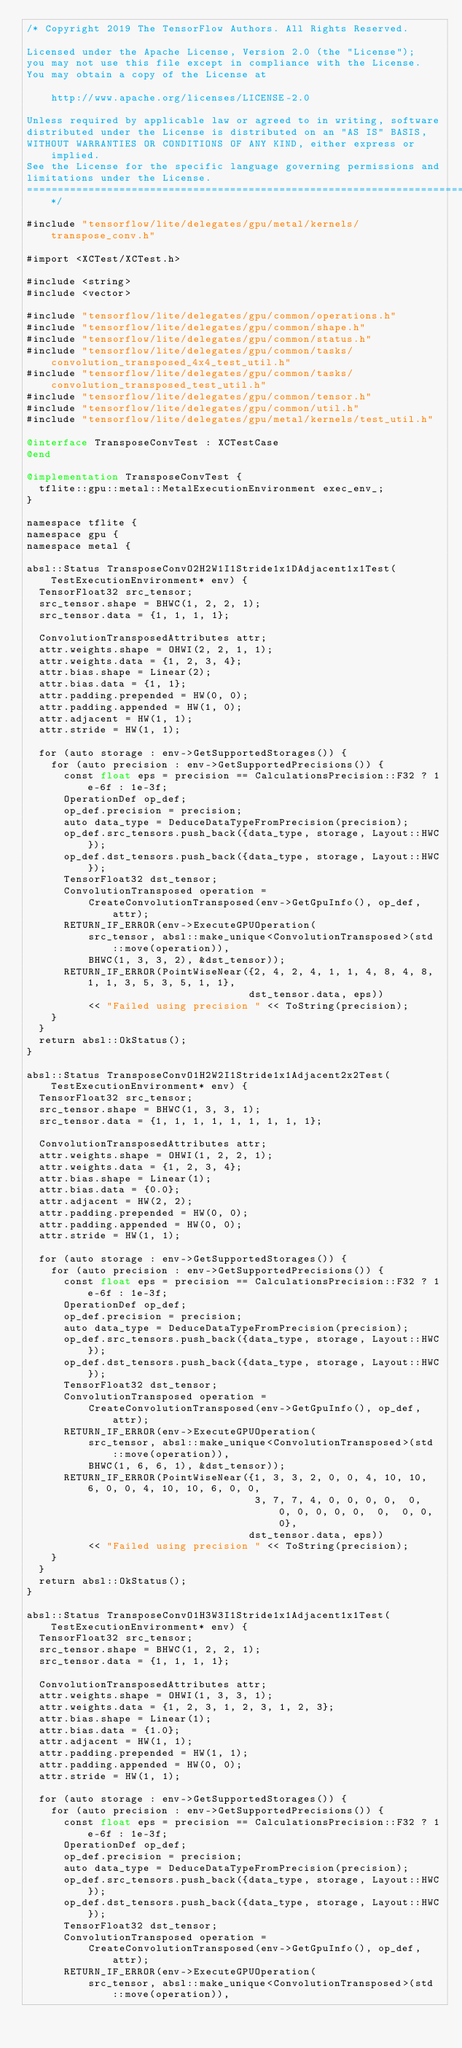<code> <loc_0><loc_0><loc_500><loc_500><_ObjectiveC_>/* Copyright 2019 The TensorFlow Authors. All Rights Reserved.

Licensed under the Apache License, Version 2.0 (the "License");
you may not use this file except in compliance with the License.
You may obtain a copy of the License at

    http://www.apache.org/licenses/LICENSE-2.0

Unless required by applicable law or agreed to in writing, software
distributed under the License is distributed on an "AS IS" BASIS,
WITHOUT WARRANTIES OR CONDITIONS OF ANY KIND, either express or implied.
See the License for the specific language governing permissions and
limitations under the License.
==============================================================================*/

#include "tensorflow/lite/delegates/gpu/metal/kernels/transpose_conv.h"

#import <XCTest/XCTest.h>

#include <string>
#include <vector>

#include "tensorflow/lite/delegates/gpu/common/operations.h"
#include "tensorflow/lite/delegates/gpu/common/shape.h"
#include "tensorflow/lite/delegates/gpu/common/status.h"
#include "tensorflow/lite/delegates/gpu/common/tasks/convolution_transposed_4x4_test_util.h"
#include "tensorflow/lite/delegates/gpu/common/tasks/convolution_transposed_test_util.h"
#include "tensorflow/lite/delegates/gpu/common/tensor.h"
#include "tensorflow/lite/delegates/gpu/common/util.h"
#include "tensorflow/lite/delegates/gpu/metal/kernels/test_util.h"

@interface TransposeConvTest : XCTestCase
@end

@implementation TransposeConvTest {
  tflite::gpu::metal::MetalExecutionEnvironment exec_env_;
}

namespace tflite {
namespace gpu {
namespace metal {

absl::Status TransposeConvO2H2W1I1Stride1x1DAdjacent1x1Test(TestExecutionEnvironment* env) {
  TensorFloat32 src_tensor;
  src_tensor.shape = BHWC(1, 2, 2, 1);
  src_tensor.data = {1, 1, 1, 1};

  ConvolutionTransposedAttributes attr;
  attr.weights.shape = OHWI(2, 2, 1, 1);
  attr.weights.data = {1, 2, 3, 4};
  attr.bias.shape = Linear(2);
  attr.bias.data = {1, 1};
  attr.padding.prepended = HW(0, 0);
  attr.padding.appended = HW(1, 0);
  attr.adjacent = HW(1, 1);
  attr.stride = HW(1, 1);

  for (auto storage : env->GetSupportedStorages()) {
    for (auto precision : env->GetSupportedPrecisions()) {
      const float eps = precision == CalculationsPrecision::F32 ? 1e-6f : 1e-3f;
      OperationDef op_def;
      op_def.precision = precision;
      auto data_type = DeduceDataTypeFromPrecision(precision);
      op_def.src_tensors.push_back({data_type, storage, Layout::HWC});
      op_def.dst_tensors.push_back({data_type, storage, Layout::HWC});
      TensorFloat32 dst_tensor;
      ConvolutionTransposed operation =
          CreateConvolutionTransposed(env->GetGpuInfo(), op_def, attr);
      RETURN_IF_ERROR(env->ExecuteGPUOperation(
          src_tensor, absl::make_unique<ConvolutionTransposed>(std::move(operation)),
          BHWC(1, 3, 3, 2), &dst_tensor));
      RETURN_IF_ERROR(PointWiseNear({2, 4, 2, 4, 1, 1, 4, 8, 4, 8, 1, 1, 3, 5, 3, 5, 1, 1},
                                    dst_tensor.data, eps))
          << "Failed using precision " << ToString(precision);
    }
  }
  return absl::OkStatus();
}

absl::Status TransposeConvO1H2W2I1Stride1x1Adjacent2x2Test(TestExecutionEnvironment* env) {
  TensorFloat32 src_tensor;
  src_tensor.shape = BHWC(1, 3, 3, 1);
  src_tensor.data = {1, 1, 1, 1, 1, 1, 1, 1, 1};

  ConvolutionTransposedAttributes attr;
  attr.weights.shape = OHWI(1, 2, 2, 1);
  attr.weights.data = {1, 2, 3, 4};
  attr.bias.shape = Linear(1);
  attr.bias.data = {0.0};
  attr.adjacent = HW(2, 2);
  attr.padding.prepended = HW(0, 0);
  attr.padding.appended = HW(0, 0);
  attr.stride = HW(1, 1);

  for (auto storage : env->GetSupportedStorages()) {
    for (auto precision : env->GetSupportedPrecisions()) {
      const float eps = precision == CalculationsPrecision::F32 ? 1e-6f : 1e-3f;
      OperationDef op_def;
      op_def.precision = precision;
      auto data_type = DeduceDataTypeFromPrecision(precision);
      op_def.src_tensors.push_back({data_type, storage, Layout::HWC});
      op_def.dst_tensors.push_back({data_type, storage, Layout::HWC});
      TensorFloat32 dst_tensor;
      ConvolutionTransposed operation =
          CreateConvolutionTransposed(env->GetGpuInfo(), op_def, attr);
      RETURN_IF_ERROR(env->ExecuteGPUOperation(
          src_tensor, absl::make_unique<ConvolutionTransposed>(std::move(operation)),
          BHWC(1, 6, 6, 1), &dst_tensor));
      RETURN_IF_ERROR(PointWiseNear({1, 3, 3, 2, 0, 0, 4, 10, 10, 6, 0, 0, 4, 10, 10, 6, 0, 0,
                                     3, 7, 7, 4, 0, 0, 0, 0,  0,  0, 0, 0, 0, 0,  0,  0, 0, 0},
                                    dst_tensor.data, eps))
          << "Failed using precision " << ToString(precision);
    }
  }
  return absl::OkStatus();
}

absl::Status TransposeConvO1H3W3I1Stride1x1Adjacent1x1Test(TestExecutionEnvironment* env) {
  TensorFloat32 src_tensor;
  src_tensor.shape = BHWC(1, 2, 2, 1);
  src_tensor.data = {1, 1, 1, 1};

  ConvolutionTransposedAttributes attr;
  attr.weights.shape = OHWI(1, 3, 3, 1);
  attr.weights.data = {1, 2, 3, 1, 2, 3, 1, 2, 3};
  attr.bias.shape = Linear(1);
  attr.bias.data = {1.0};
  attr.adjacent = HW(1, 1);
  attr.padding.prepended = HW(1, 1);
  attr.padding.appended = HW(0, 0);
  attr.stride = HW(1, 1);

  for (auto storage : env->GetSupportedStorages()) {
    for (auto precision : env->GetSupportedPrecisions()) {
      const float eps = precision == CalculationsPrecision::F32 ? 1e-6f : 1e-3f;
      OperationDef op_def;
      op_def.precision = precision;
      auto data_type = DeduceDataTypeFromPrecision(precision);
      op_def.src_tensors.push_back({data_type, storage, Layout::HWC});
      op_def.dst_tensors.push_back({data_type, storage, Layout::HWC});
      TensorFloat32 dst_tensor;
      ConvolutionTransposed operation =
          CreateConvolutionTransposed(env->GetGpuInfo(), op_def, attr);
      RETURN_IF_ERROR(env->ExecuteGPUOperation(
          src_tensor, absl::make_unique<ConvolutionTransposed>(std::move(operation)),</code> 